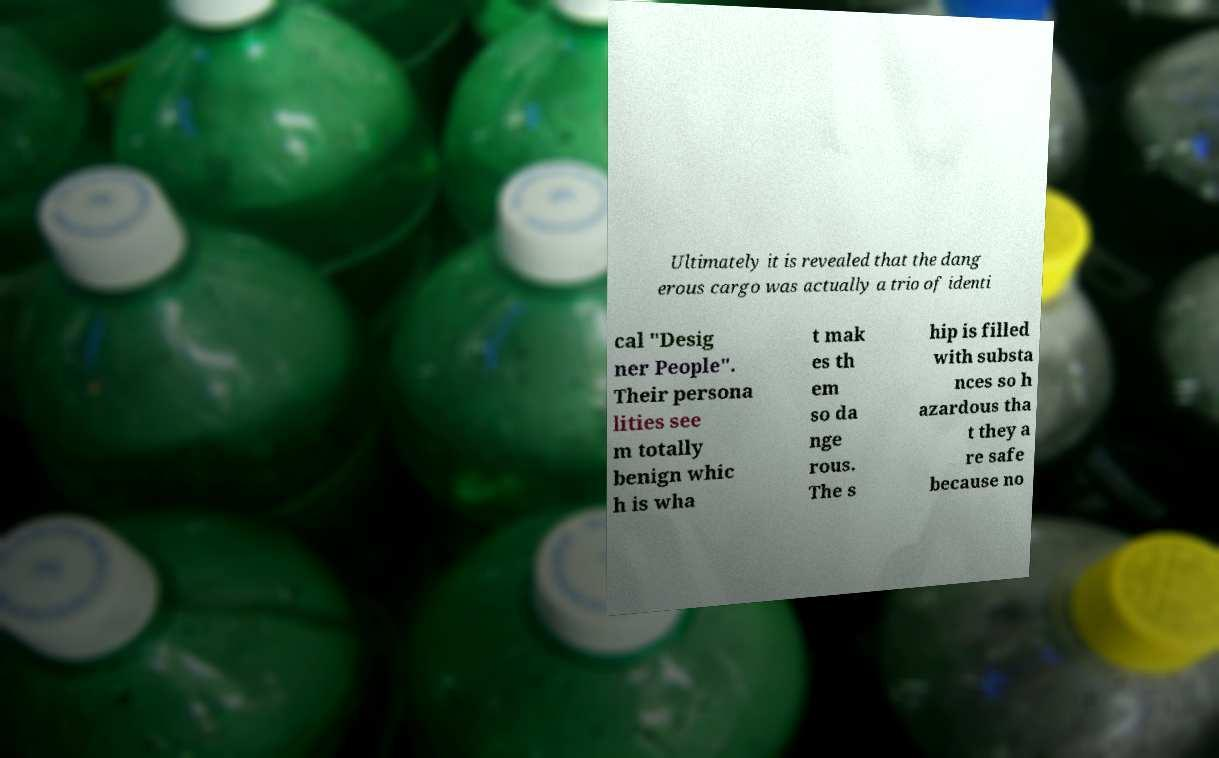Please identify and transcribe the text found in this image. Ultimately it is revealed that the dang erous cargo was actually a trio of identi cal "Desig ner People". Their persona lities see m totally benign whic h is wha t mak es th em so da nge rous. The s hip is filled with substa nces so h azardous tha t they a re safe because no 